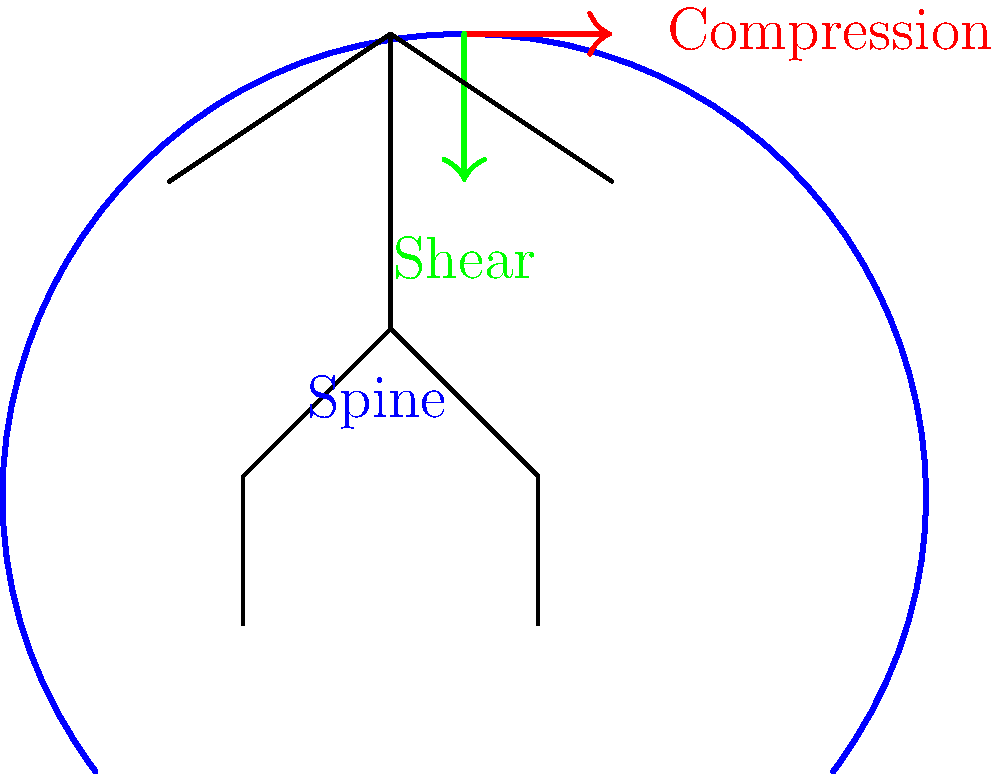When a person is sitting and reading a book, which biomechanical force acting on the spine is most likely to increase and potentially cause discomfort or injury over time? To answer this question, let's consider the biomechanical forces acting on the spine while sitting and reading:

1. Compression force: This is the downward force acting along the axis of the spine due to the weight of the upper body and head.

2. Shear force: This is the force acting perpendicular to the axis of the spine, often caused by poor posture or uneven weight distribution.

When sitting and reading, especially for prolonged periods:

a) The person's head is often tilted forward to look at the book.
b) This forward tilt increases the effective weight of the head on the spine.
c) The increased weight leads to greater compression force on the intervertebral discs and vertebrae.
d) Additionally, the forward tilt can create an imbalance, increasing shear forces.

Of these forces, the compression force is most likely to increase significantly due to the forward head posture commonly adopted while reading. This increased compression can lead to:

- Strain on the muscles and ligaments supporting the spine
- Increased pressure on intervertebral discs
- Potential long-term issues such as disc degeneration or herniation

While shear forces also increase, the compression force is typically the primary concern in this scenario.
Answer: Compression force 